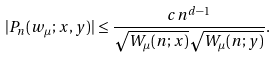Convert formula to latex. <formula><loc_0><loc_0><loc_500><loc_500>| P _ { n } ( w _ { \mu } ; x , y ) | \leq \frac { c n ^ { d - 1 } } { \sqrt { W _ { \mu } ( n ; x ) } \sqrt { W _ { \mu } ( n ; y ) } } .</formula> 